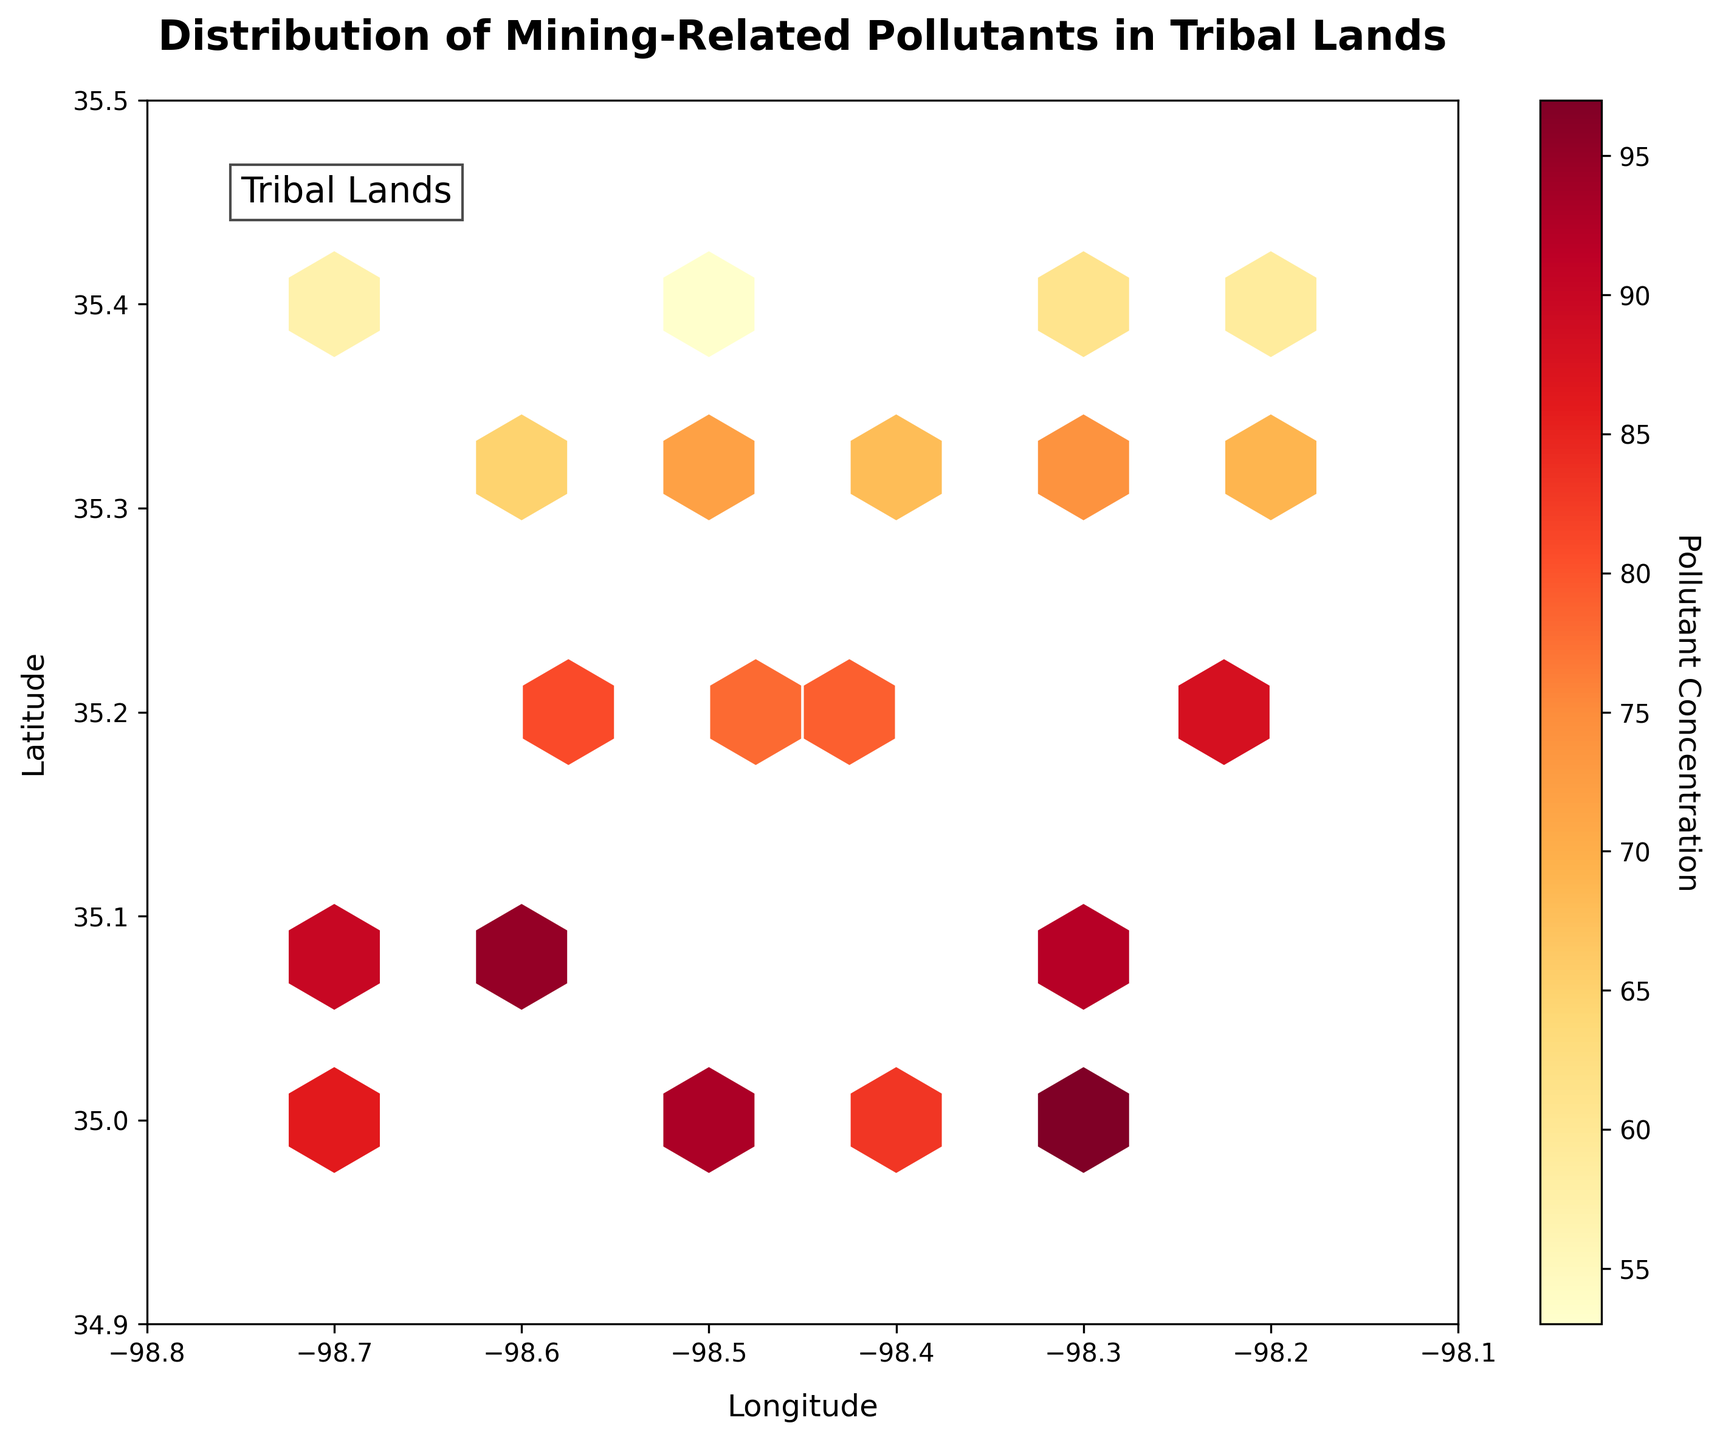What is the title of the plot? The title is located at the top of the plot and is clearly labeled to help viewers understand what the plot represents. In this case, the title describes the distribution of pollutants.
Answer: Distribution of Mining-Related Pollutants in Tribal Lands What does the color bar represent? The color bar (or color scale) is located on the side of the plot and indicates what the colors in the hexbin plot correspond to. Here, it shows the levels of pollutant concentration.
Answer: Pollutant Concentration Between which two latitude values is the concentration of pollutants highest? To find the latitude values with the highest pollutant concentration, we need to look at the spots with the most intense colors, usually reds or oranges, and see where they lie on the vertical axis.
Answer: 35.1 and 35.3 Is the pollutant concentration uniform across the tribal lands? Observing the distribution of colors (or hexagons) and their intensity in the plot, we can see whether the pollutant concentration is evenly spread or uneven.
Answer: No Which general area has the lowest pollutant concentration? By identifying the regions with the lightest colors (typically yellows or light oranges), we can determine which areas have the lowest pollutant levels. These are usually at the extremes.
Answer: Near the latitude of 34.9 and longitude of -98.7 to -98.8 What is the pollutant concentration around the coordinates (-98.5, 35.2)? We locate the point (-98.5, 35.2) on the plot and observe the color of the hexagon that contains this point, then refer to the color bar to find the pollutant concentration.
Answer: 78 At which longitude do you observe the highest pollutant concentration? We find the darkest hexagons (indicating highest pollutant concentration) and read the corresponding longitude from the horizontal axis.
Answer: -98.3 Does the plot indicate any specific labeling for the tribal lands? Observing the plot, we can see if there is any text, annotation, or special marking that labels the tribal lands directly on the plot.
Answer: Yes, labeled as "Tribal Lands" What is the range of the longitude values shown in the plot? By looking at the horizontal axis (x-axis), we can read the minimum and maximum longitude values depicted on the plot.
Answer: -98.8 to -98.1 How is the pollutant concentration around the center coordinates (-98.4, 35.25)? Locate the center coordinates roughly around (-98.4, 35.25) on the plot, observe the color of the hexagon at that position, and refer to the color bar to determine the concentration level.
Answer: Moderate to High 